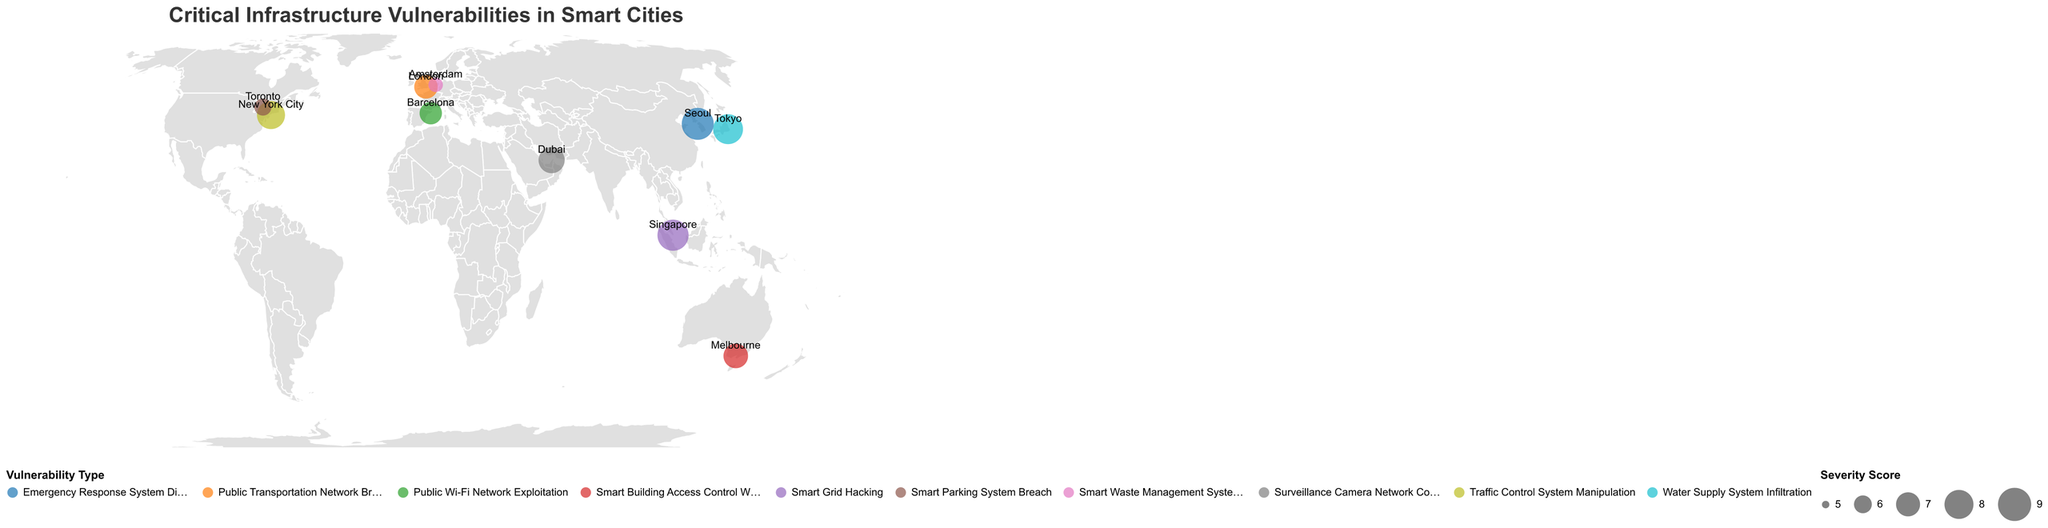What is the title of the figure? The title of the figure is displayed at the top and reads "Critical Infrastructure Vulnerabilities in Smart Cities."
Answer: Critical Infrastructure Vulnerabilities in Smart Cities Which city has the highest Severity Score? By looking at the size of the circles, Seoul has the largest circle, indicating the highest Severity Score.
Answer: Seoul What Vulnerability Type does New York City have? Hovering over or observing the legend and color-coding related to the circles, New York City's color corresponds to "Traffic Control System Manipulation."
Answer: Traffic Control System Manipulation How many cities are depicted in the figure? By counting the number of circles on the map, which represent different cities, there are 10 cities depicted in the figure.
Answer: 10 Which city has the smallest Severity Score, and what is that score? Amsterdam has the smallest circle corresponding to the lowest Severity Score, which is 5.6.
Answer: Amsterdam, 5.6 What is the average Severity Score of all cities displayed in the figure? Adding up all the Severity Scores and then dividing by the number of cities: (8.5 + 7.8 + 6.9 + 8.2 + 7.4 + 5.6 + 6.7 + 8.7 + 5.9 + 7.1) / 10 = 72.8 / 10
Answer: 7.28 Which city represents a "Public Wi-Fi Network Exploitation" vulnerability, and what is its Severity Score? Observing the legend and the color corresponding to "Public Wi-Fi Network Exploitation," Barcelona is identified along with a score of 6.7.
Answer: Barcelona, 6.7 Compare the Severity Scores of Tokyo and Melbourne. Which one is greater and by how much? Tokyo’s score is 8.2 and Melbourne’s is 7.1. The difference is 8.2 - 7.1 = 1.1.
Answer: Tokyo by 1.1 What type of vulnerability is associated with Singapore, and what is its Severity Score? The tooltip or color coding indicates that Singapore has a "Smart Grid Hacking" vulnerability with a Severity Score of 8.5.
Answer: Smart Grid Hacking, 8.5 Which continent has the most cities represented in the figure? Observing the placement of the circles and their city labels, Asia has four cities: Singapore, Tokyo, Dubai, and Seoul.
Answer: Asia 